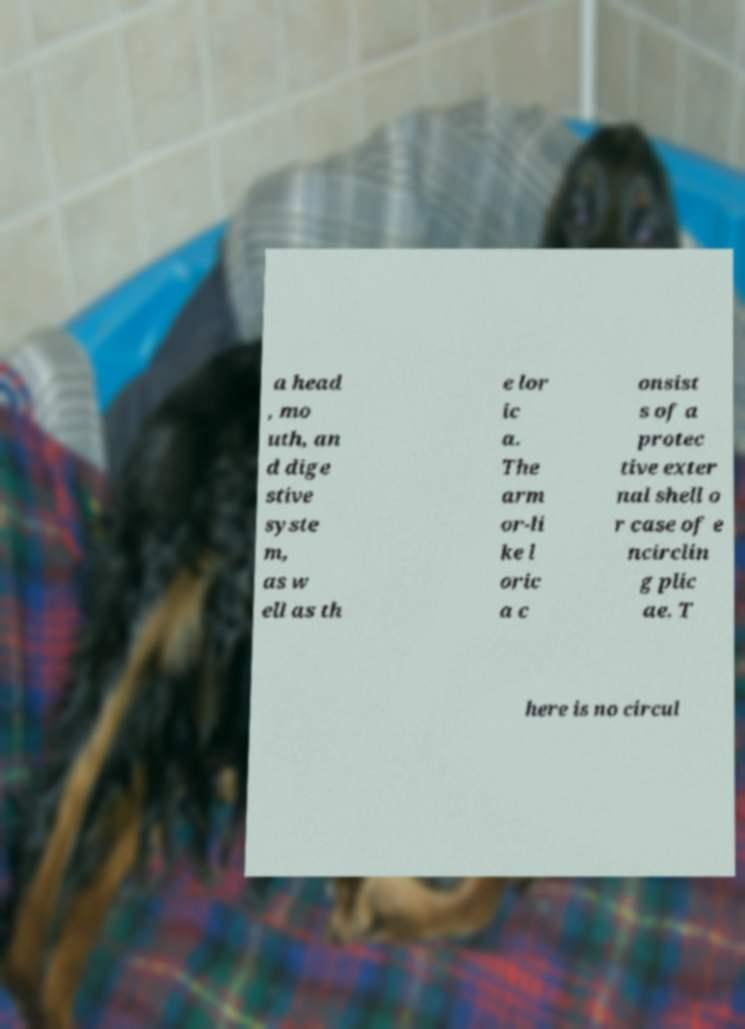What messages or text are displayed in this image? I need them in a readable, typed format. a head , mo uth, an d dige stive syste m, as w ell as th e lor ic a. The arm or-li ke l oric a c onsist s of a protec tive exter nal shell o r case of e ncirclin g plic ae. T here is no circul 